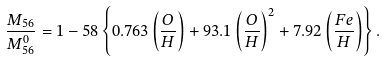Convert formula to latex. <formula><loc_0><loc_0><loc_500><loc_500>\frac { M _ { 5 6 } } { M _ { 5 6 } ^ { 0 } } = 1 - 5 8 \left \{ 0 . 7 6 3 \left ( \frac { O } { H } \right ) + 9 3 . 1 \left ( \frac { O } { H } \right ) ^ { 2 } + 7 . 9 2 \left ( \frac { F e } { H } \right ) \right \} .</formula> 